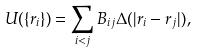<formula> <loc_0><loc_0><loc_500><loc_500>U ( \{ r _ { i } \} ) = \sum _ { i < j } B _ { i j } \Delta ( | r _ { i } - r _ { j } | ) ,</formula> 